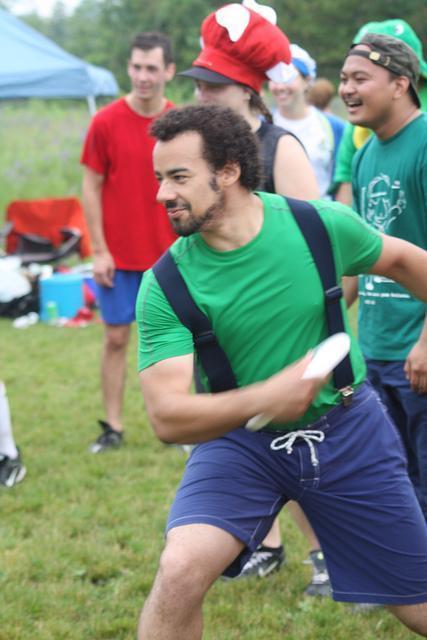How many faces can be seen?
Give a very brief answer. 5. How many people can be seen?
Give a very brief answer. 6. 